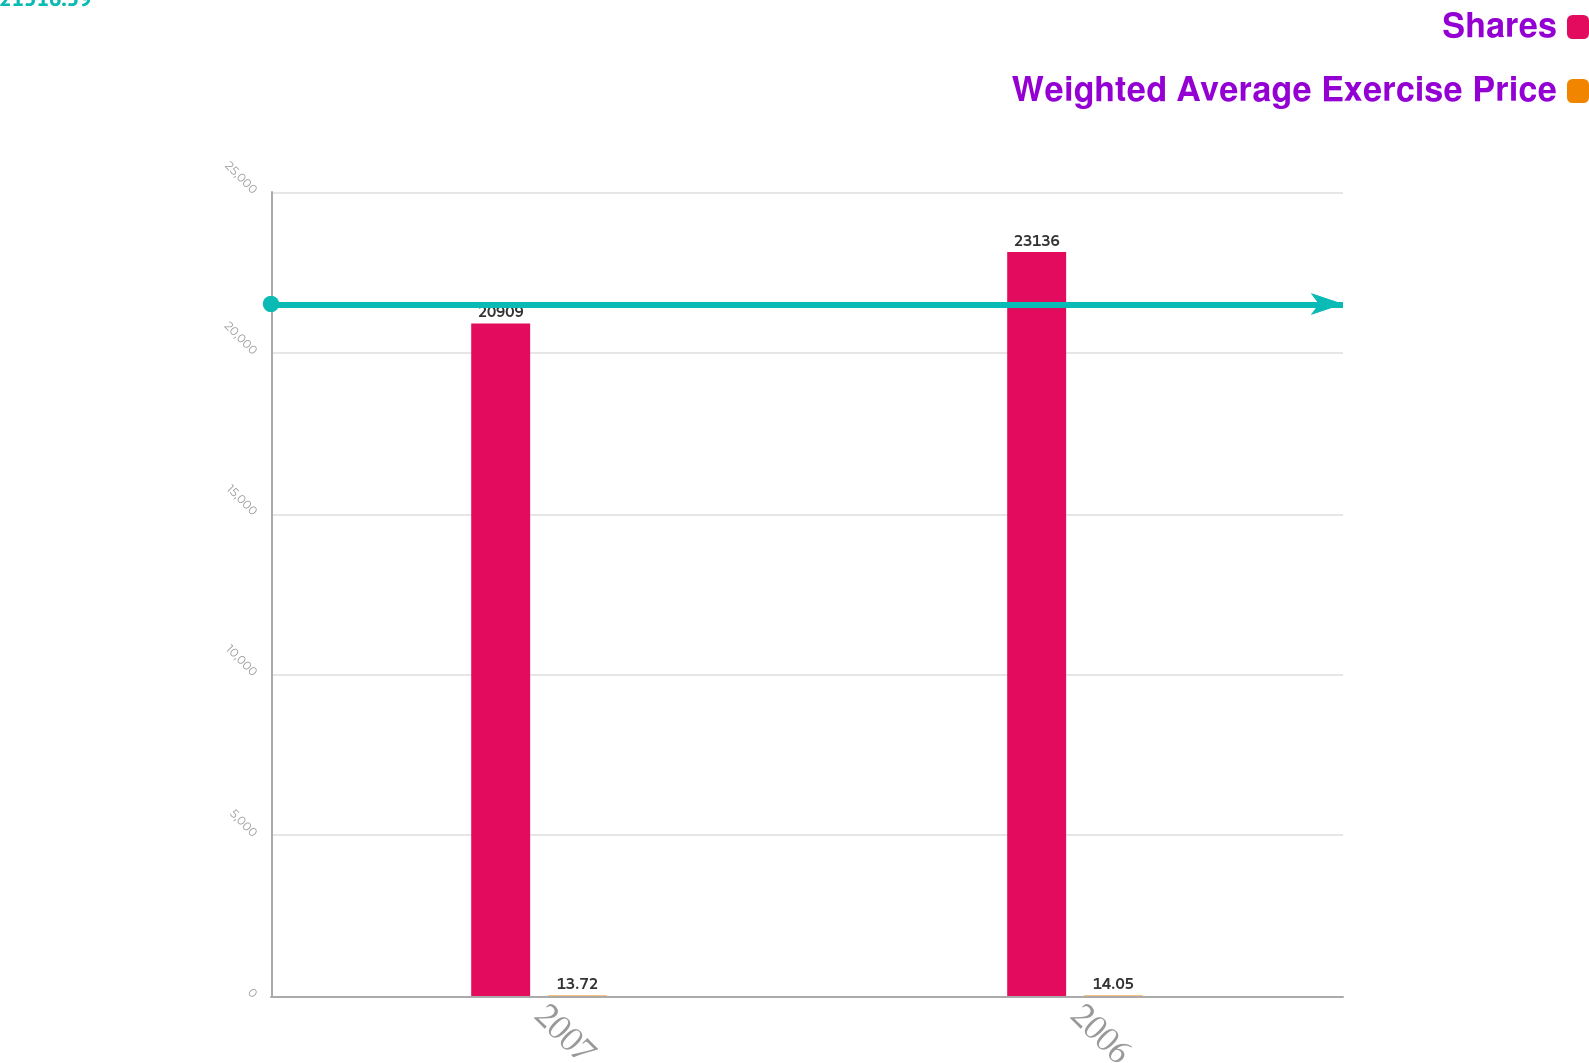Convert chart. <chart><loc_0><loc_0><loc_500><loc_500><stacked_bar_chart><ecel><fcel>2007<fcel>2006<nl><fcel>Shares<fcel>20909<fcel>23136<nl><fcel>Weighted Average Exercise Price<fcel>13.72<fcel>14.05<nl></chart> 